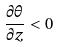Convert formula to latex. <formula><loc_0><loc_0><loc_500><loc_500>\frac { \partial \theta } { \partial z } < 0</formula> 